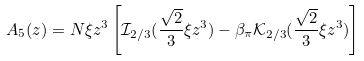Convert formula to latex. <formula><loc_0><loc_0><loc_500><loc_500>A _ { 5 } ( z ) = N \xi z ^ { 3 } \left [ \mathcal { I } _ { 2 / 3 } ( \frac { \sqrt { 2 } } { 3 } \xi z ^ { 3 } ) - \beta _ { \pi } \mathcal { K } _ { 2 / 3 } ( \frac { \sqrt { 2 } } { 3 } \xi z ^ { 3 } ) \right ]</formula> 